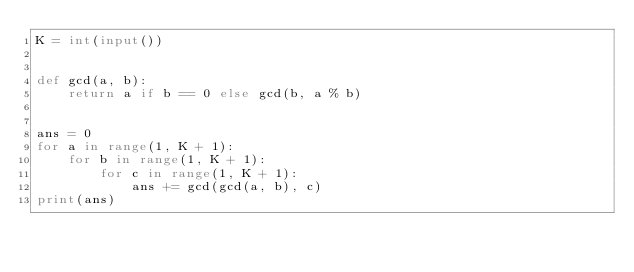<code> <loc_0><loc_0><loc_500><loc_500><_Python_>K = int(input())


def gcd(a, b):
    return a if b == 0 else gcd(b, a % b)


ans = 0
for a in range(1, K + 1):
    for b in range(1, K + 1):
        for c in range(1, K + 1):
            ans += gcd(gcd(a, b), c)
print(ans)
</code> 